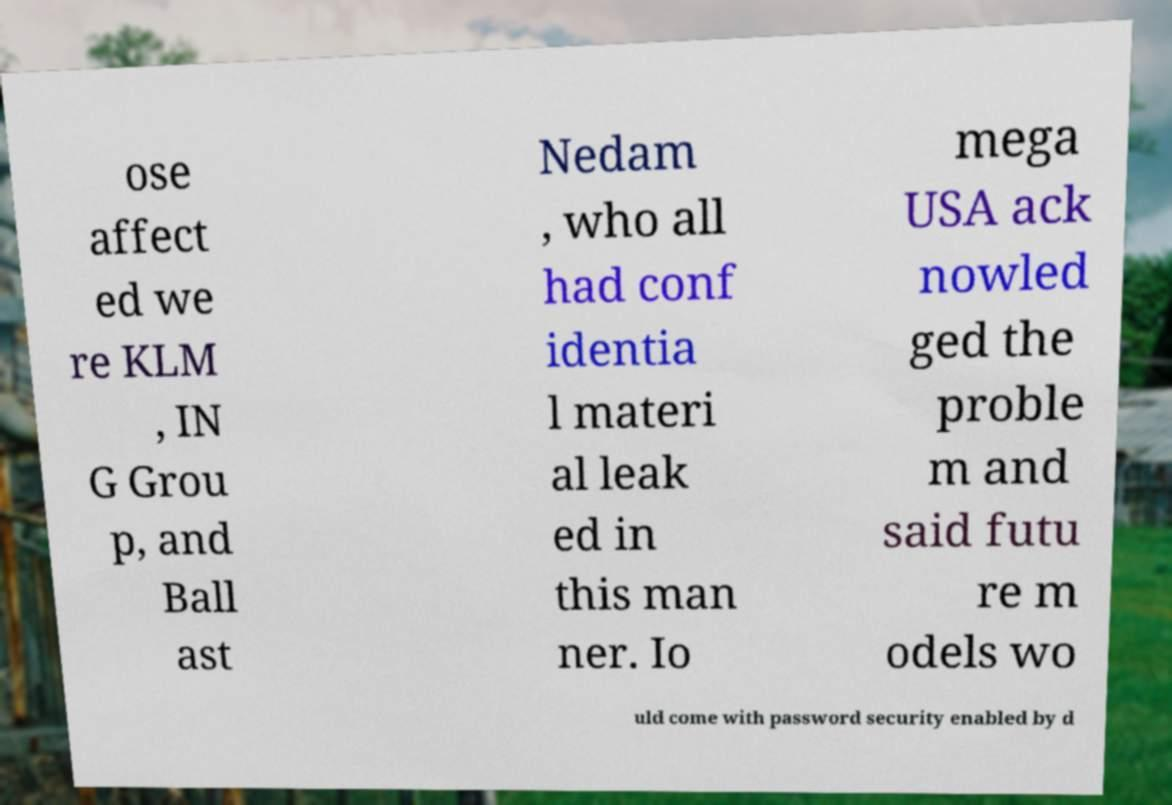I need the written content from this picture converted into text. Can you do that? ose affect ed we re KLM , IN G Grou p, and Ball ast Nedam , who all had conf identia l materi al leak ed in this man ner. Io mega USA ack nowled ged the proble m and said futu re m odels wo uld come with password security enabled by d 